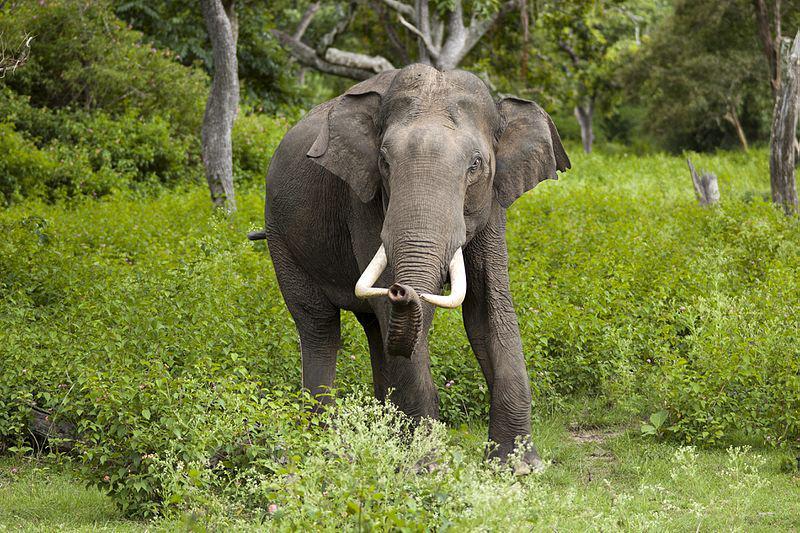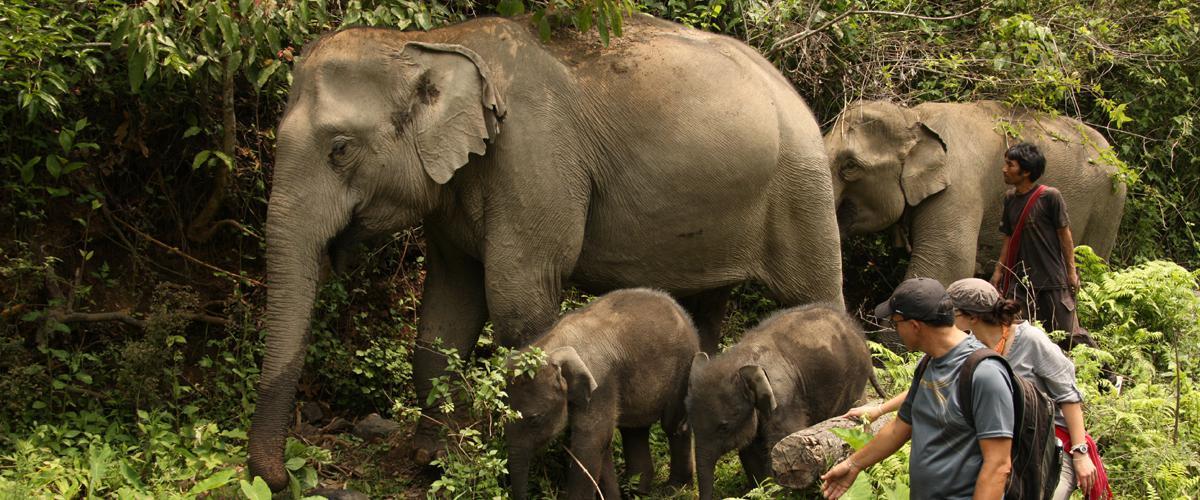The first image is the image on the left, the second image is the image on the right. Given the left and right images, does the statement "The elephant on the left is being attended to by humans." hold true? Answer yes or no. No. The first image is the image on the left, the second image is the image on the right. Considering the images on both sides, is "The left image shows humans interacting with an elephant." valid? Answer yes or no. No. 